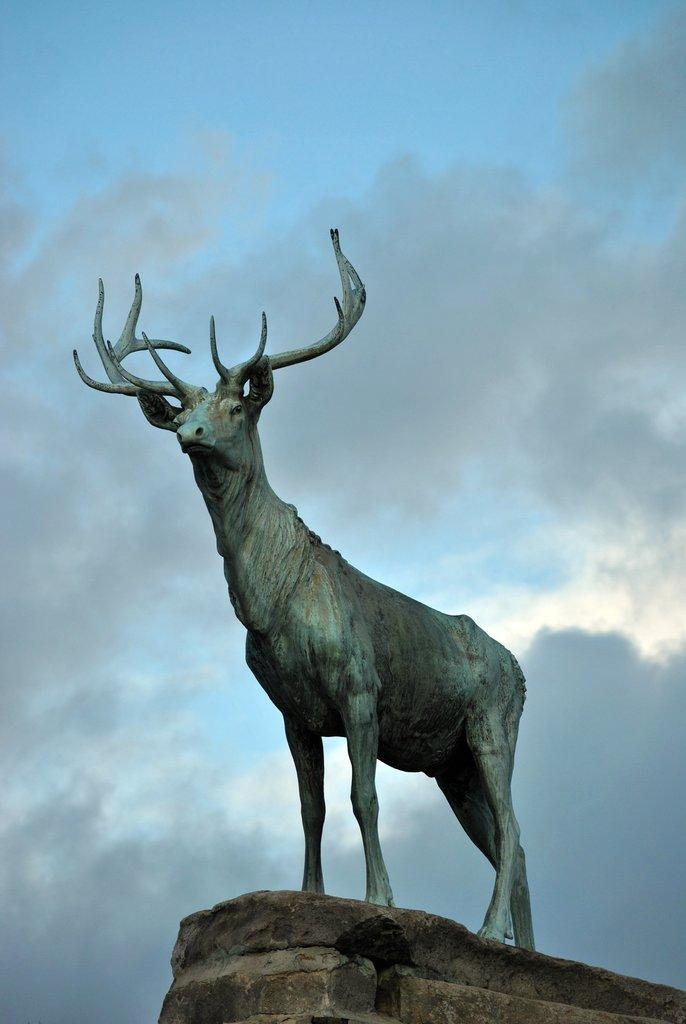What is the main subject of the image? There is a statue of an animal in the image. What color is the statue? The statue is blue in color. What can be seen in the background of the image? There are clouds and a blue sky visible in the background of the image. What type of belief is represented by the statue in the image? There is no indication of any belief being represented by the statue in the image. The statue is simply a blue animal. 